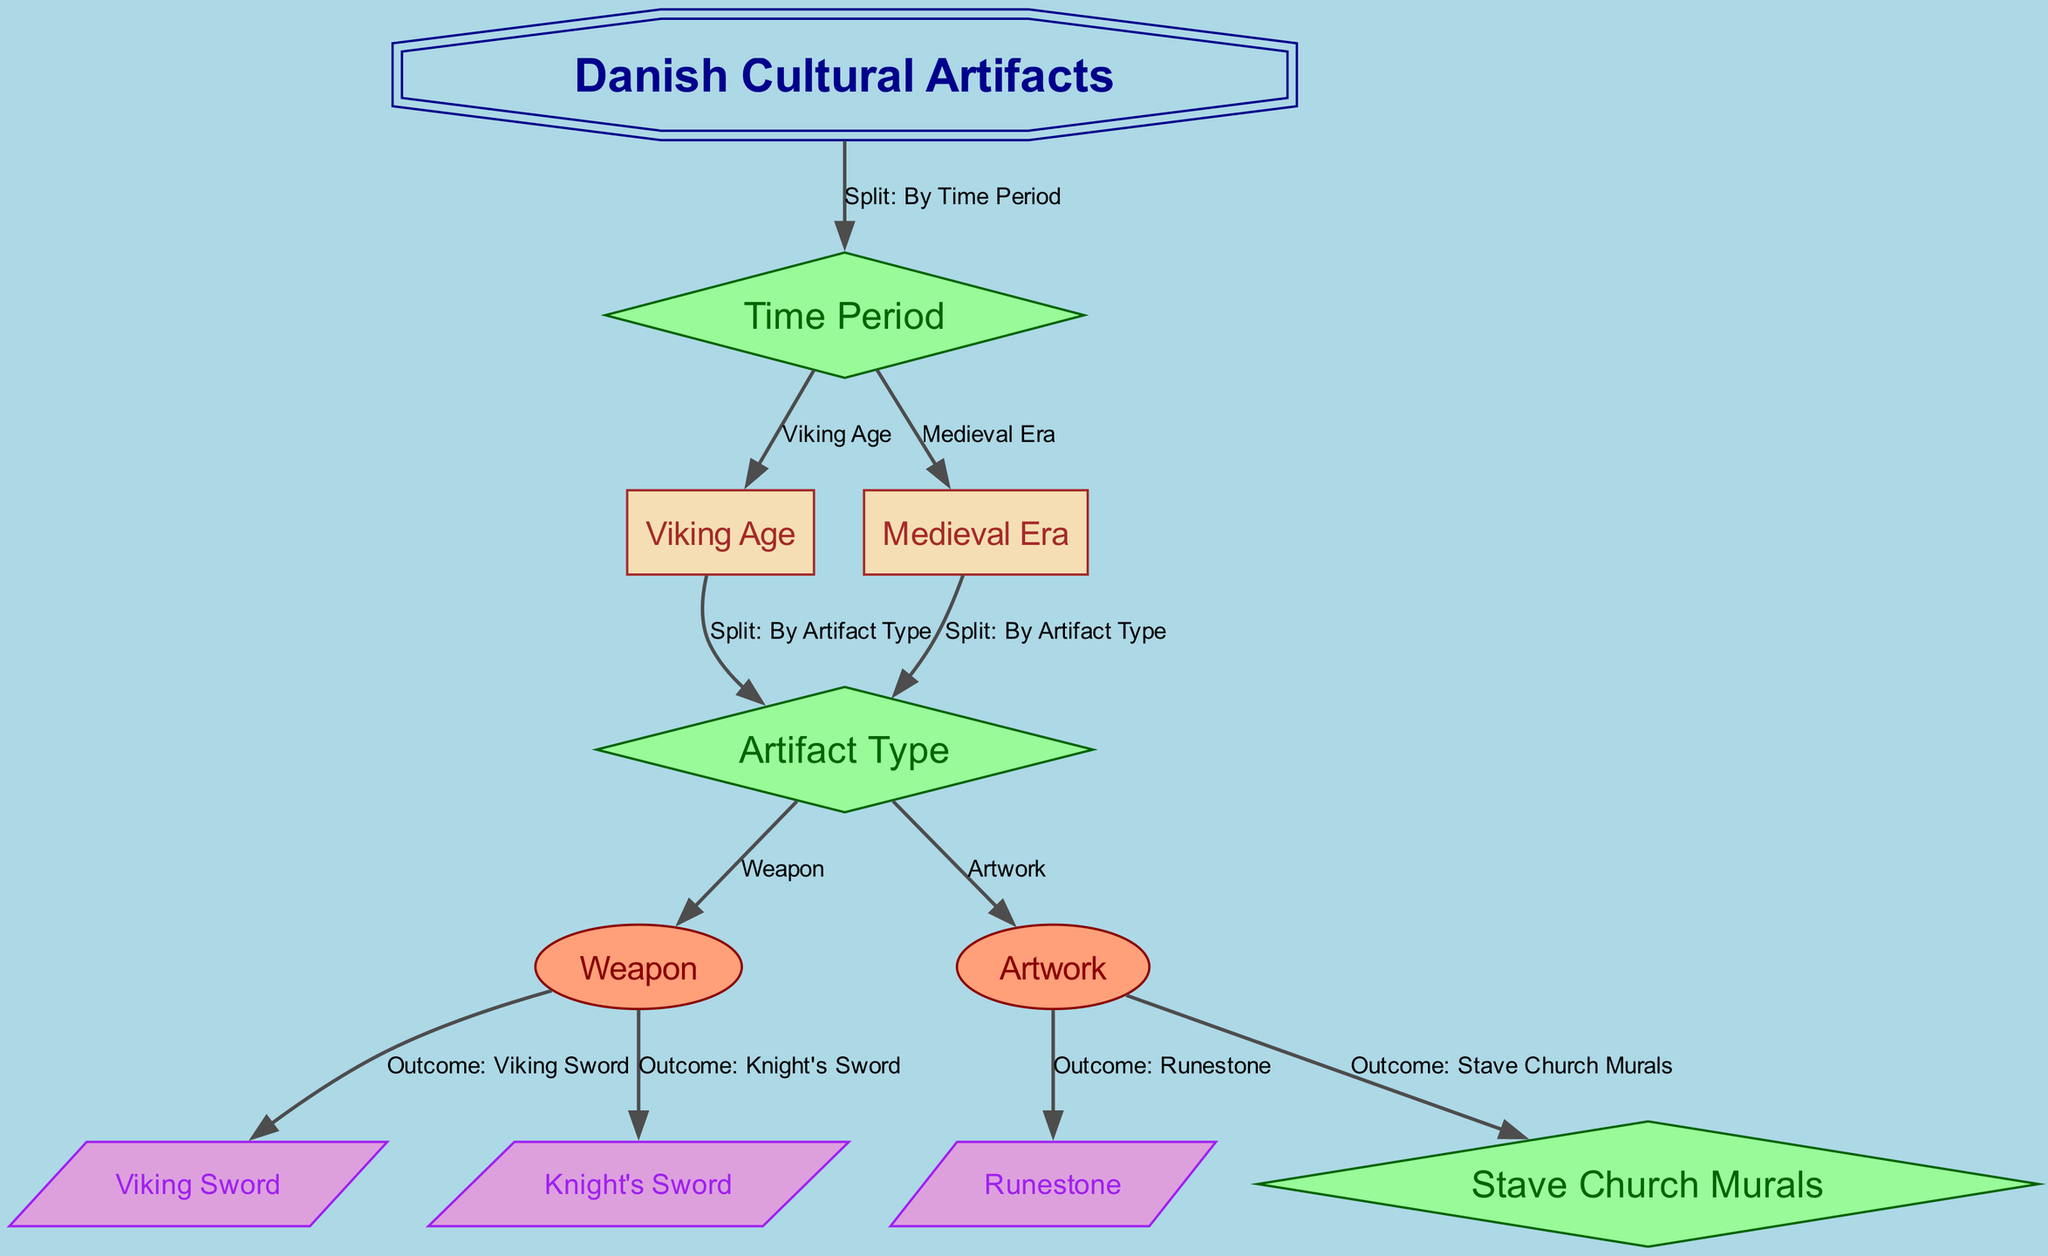What is the root node of the diagram? The root node is labeled "Danish Cultural Artifacts." This is the starting point of the decision tree from which all subsequent nodes branch out.
Answer: Danish Cultural Artifacts How many total nodes are in the diagram? The diagram contains a total of 10 nodes, each representing different aspects of Danish cultural artifacts, including time periods and artifact types.
Answer: 10 What is the first split criterion in the decision tree? The diagram shows that the first split criterion is "By Time Period," which distinguishes artifacts based on whether they belong to the Viking Age or the Medieval Era.
Answer: By Time Period Which artifact type is reached from the Viking Age node? From the Viking Age node, the decision tree splits further into the "Artifact Type," which includes either "Weapon" or "Artwork." The first outcome reached from here is "Viking Sword" as a specific artifact type under "Weapon."
Answer: Viking Sword How many outcomes are associated with the Medieval Era? There are two outcomes associated with the Medieval Era, which are "Knight's Sword" and "Stave Church Murals," both stemming from the "Artifact Type" split.
Answer: 2 What is the label of the edge connecting the Viking Age node to the Artifact Type node? The edge between the Viking Age node and the Artifact Type node is labeled "Split: By Artifact Type," indicating that this split categorizes artifacts further based on their type.
Answer: Split: By Artifact Type What are the final outcomes for the Artifact Type classified as Artwork in the Viking Age? The final outcome for the Artifact Type classified as Artwork in the Viking Age is "Runestone." This outcome is achieved by following the appropriate node connections from the Viking Age through the Artifact Type split.
Answer: Runestone Which node directly follows the Medieval Era node? The Medieval Era node directly leads to the "Artifact Type" node, indicating that once the time period is established as Medieval Era, the next classification is by artifact type.
Answer: Artifact Type 